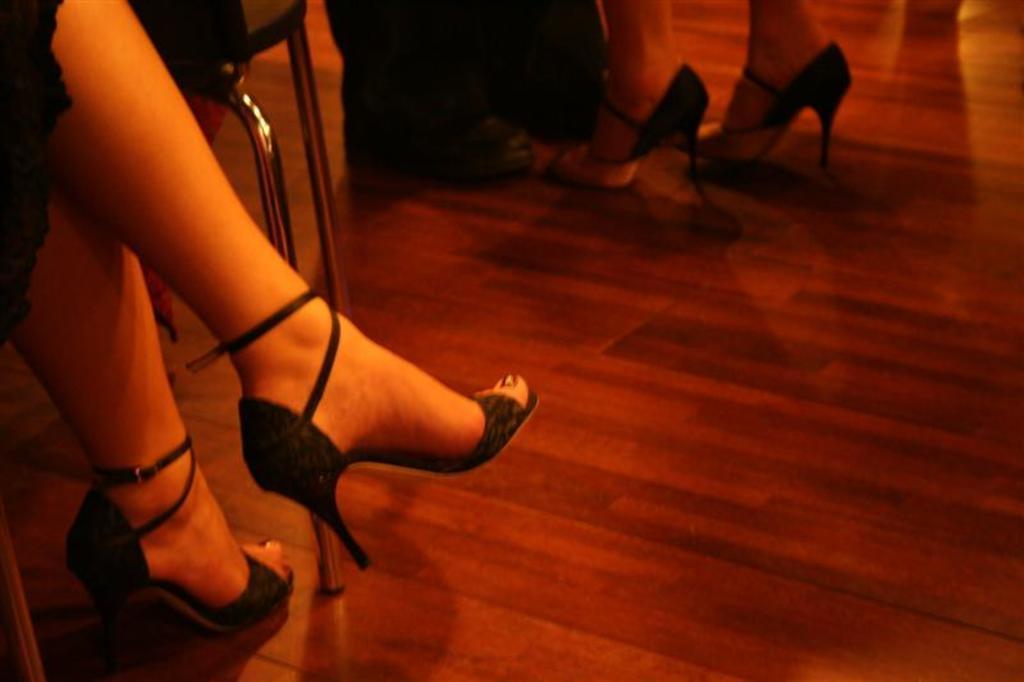Describe this image in one or two sentences. This image consists of few persons. In the front, it looks like woman legs. At the bottom, there is a floor. And we can see a chair. 